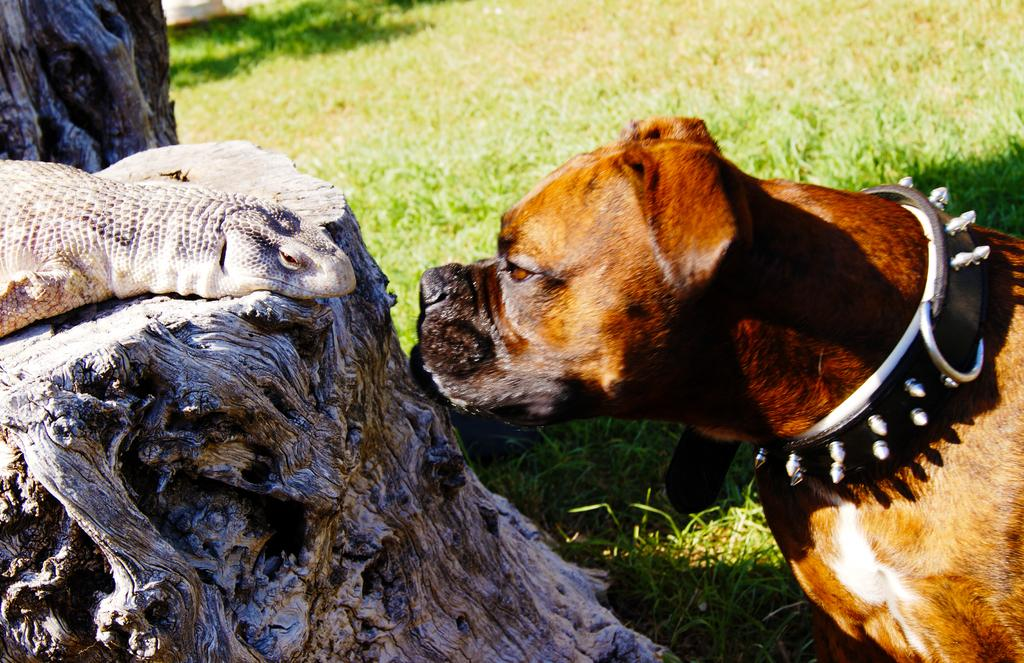What types of living organisms can be seen in the image? There are animals in the image. Can you describe the position of one of the animals? One of the animals is on the trunk of a tree. What is the ground covered with in the image? The ground in the image is covered with grass. Reasoning: Let's think step by step by step in order to produce the conversation. We start by identifying the main subject in the image, which is the animals. Then, we expand the conversation to include specific details about the animals, such as their position on the tree trunk. Finally, we describe the ground in the image, which is covered with grass. Each question is designed to elicit a specific detail about the image that is known from the provided facts. Absurd Question/Answer: What is the price of the cup being held by the animal on the tree trunk? There is no cup present in the image, and therefore no price can be determined. What is the price of the cup being held by the animal on the tree trunk? There is no cup present in the image, and therefore no price can be determined. 